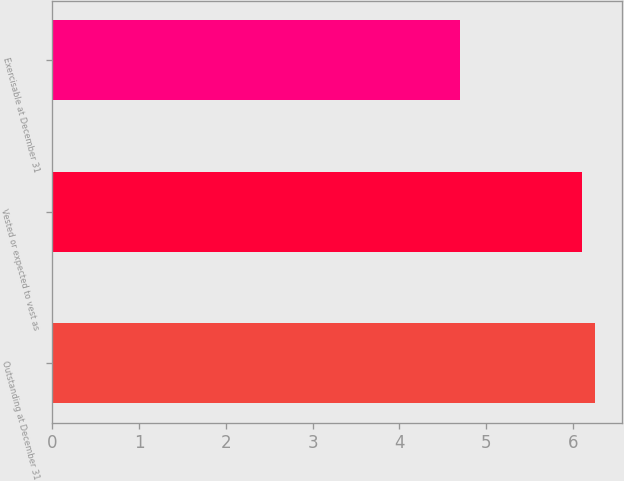Convert chart to OTSL. <chart><loc_0><loc_0><loc_500><loc_500><bar_chart><fcel>Outstanding at December 31<fcel>Vested or expected to vest as<fcel>Exercisable at December 31<nl><fcel>6.25<fcel>6.1<fcel>4.7<nl></chart> 